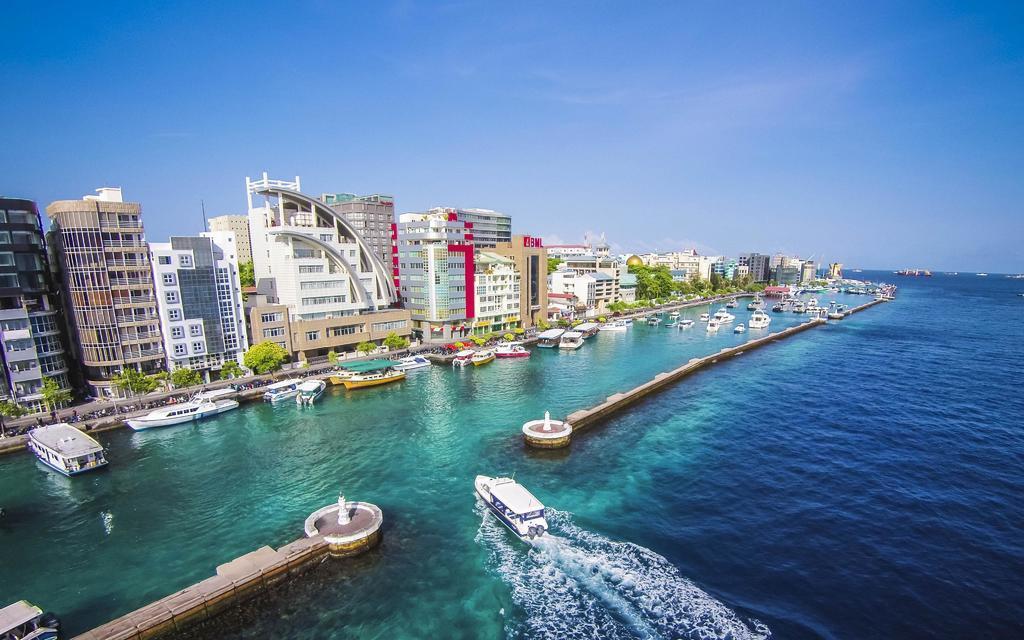In one or two sentences, can you explain what this image depicts? This image consists of many buildings along with plants. At the bottom, there is water. And we can see many boats. At the top, there is sky. 